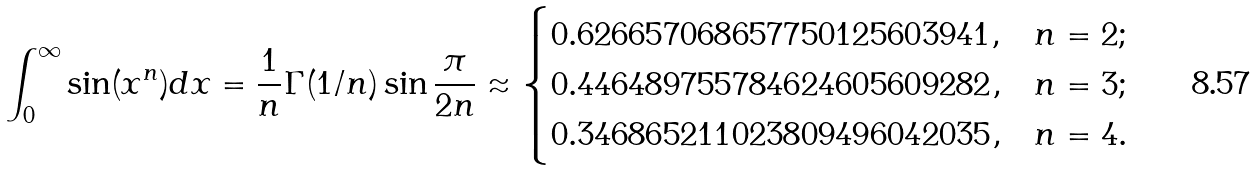<formula> <loc_0><loc_0><loc_500><loc_500>\int _ { 0 } ^ { \infty } \sin ( x ^ { n } ) d x = \frac { 1 } { n } \Gamma ( 1 / n ) \sin \frac { \pi } { 2 n } \approx \begin{cases} 0 . 6 2 6 6 5 7 0 6 8 6 5 7 7 5 0 1 2 5 6 0 3 9 4 1 , & n = 2 ; \\ 0 . 4 4 6 4 8 9 7 5 5 7 8 4 6 2 4 6 0 5 6 0 9 2 8 2 , & n = 3 ; \\ 0 . 3 4 6 8 6 5 2 1 1 0 2 3 8 0 9 4 9 6 0 4 2 0 3 5 , & n = 4 . \\ \end{cases}</formula> 